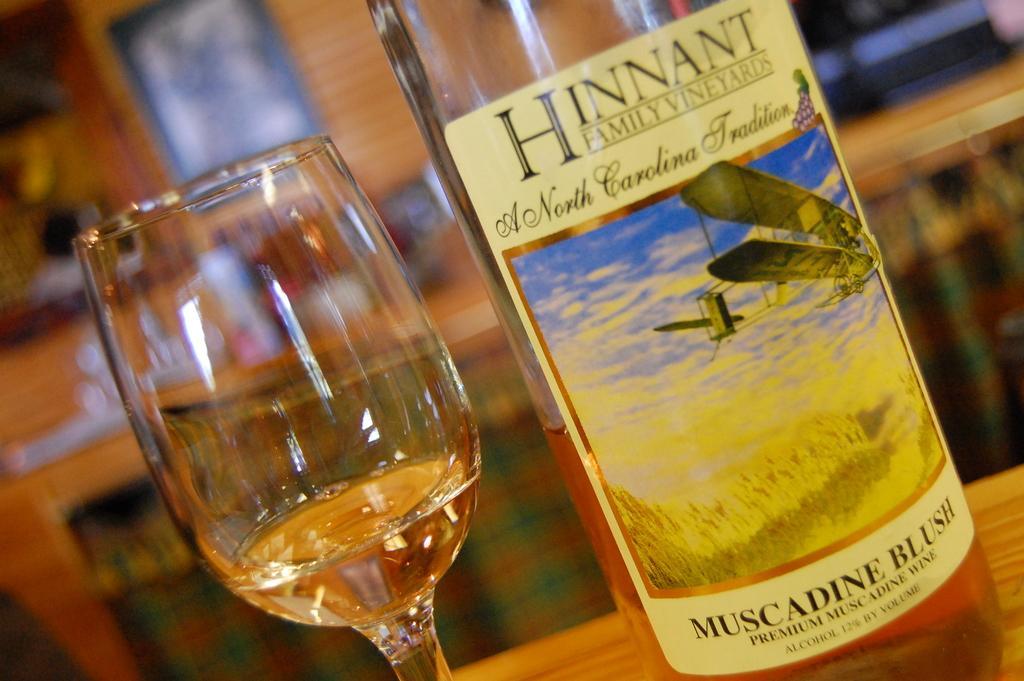In one or two sentences, can you explain what this image depicts? This picture is taken inside the room. In front, we see a wine bottle on which some text is written on it, family wine yards and beside that, we see a glass which contains wine in it. Both of them, are placed on the table. Behind that, we see a wall and a photo frame. 